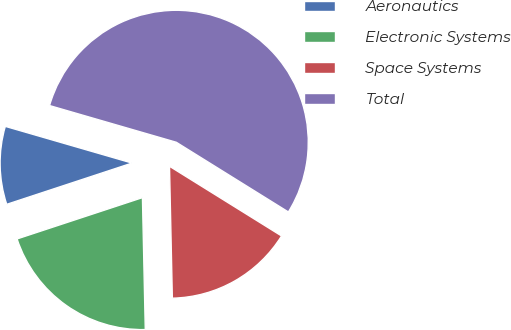<chart> <loc_0><loc_0><loc_500><loc_500><pie_chart><fcel>Aeronautics<fcel>Electronic Systems<fcel>Space Systems<fcel>Total<nl><fcel>9.55%<fcel>20.28%<fcel>15.8%<fcel>54.37%<nl></chart> 